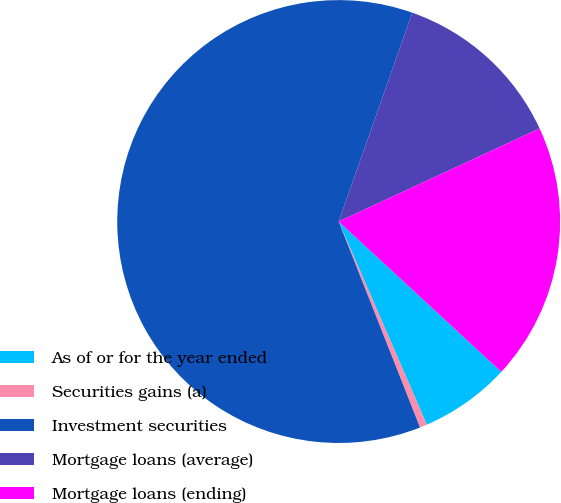<chart> <loc_0><loc_0><loc_500><loc_500><pie_chart><fcel>As of or for the year ended<fcel>Securities gains (a)<fcel>Investment securities<fcel>Mortgage loans (average)<fcel>Mortgage loans (ending)<nl><fcel>6.61%<fcel>0.53%<fcel>61.38%<fcel>12.7%<fcel>18.78%<nl></chart> 